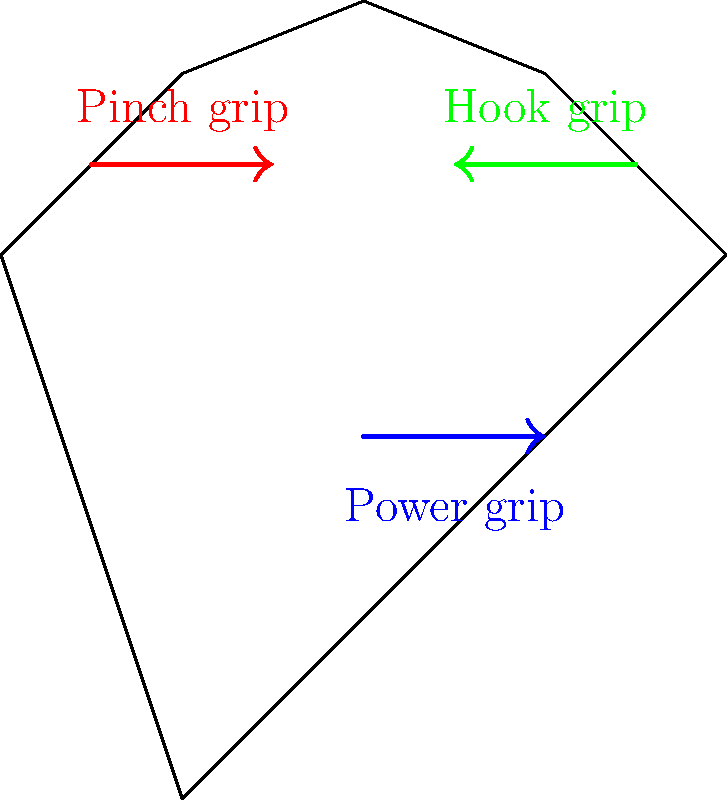When moving heavy boxes, which hand grip is most ergonomic and reduces the risk of injury? To determine the most ergonomic hand grip for moving heavy boxes, we need to consider the following factors:

1. Force distribution: The grip should distribute the weight evenly across the hand.
2. Wrist position: The grip should maintain a neutral wrist position to reduce strain.
3. Muscle engagement: The grip should engage larger muscle groups for better support.
4. Stability: The grip should provide a secure hold on the box.

Analyzing the three grips shown in the diagram:

1. Power grip (blue): 
   - Distributes force across the entire palm and fingers
   - Keeps the wrist in a neutral position
   - Engages larger forearm muscles
   - Provides a stable hold on the box

2. Pinch grip (red):
   - Concentrates force on fingertips and thumb
   - May cause wrist deviation
   - Relies mainly on smaller hand muscles
   - Less stable for heavy loads

3. Hook grip (green):
   - Distributes force across fingers
   - May cause slight wrist extension
   - Engages forearm muscles, but less than power grip
   - Moderately stable, but risk of slipping

Considering these factors, the power grip is the most ergonomic choice for moving heavy boxes. It provides the best combination of force distribution, wrist positioning, muscle engagement, and stability, thus reducing the risk of injury during the moving process.
Answer: Power grip 